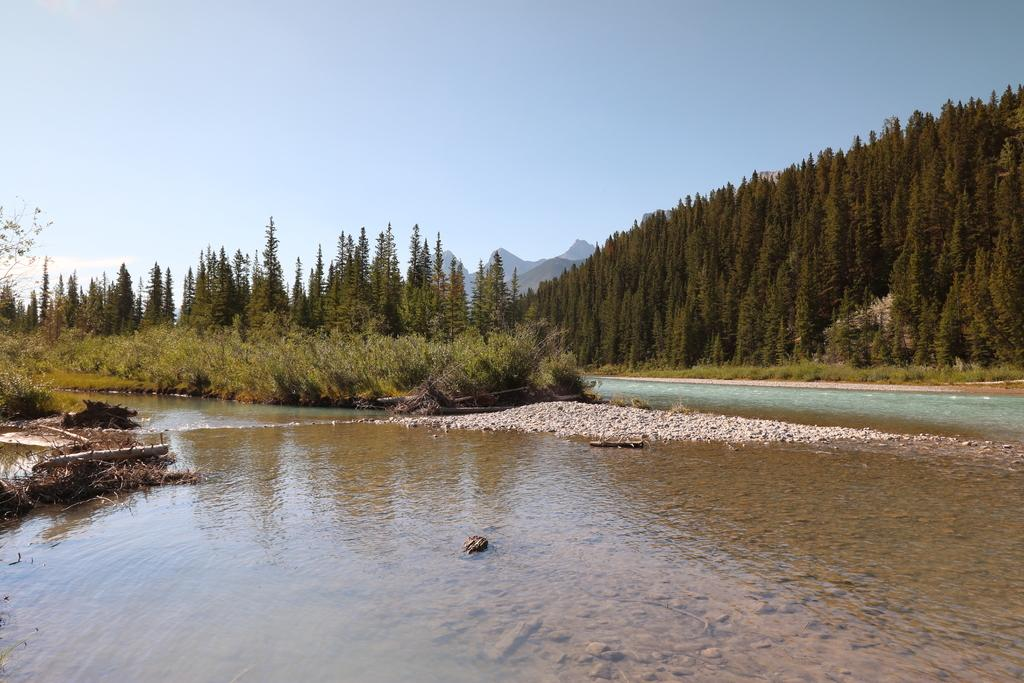What is the main subject in the center of the image? There is water in the center of the image. What can be seen in the background of the image? There are trees and hills in the background of the image. How would you describe the sky in the image? The sky is cloudy in the image. Where is the guitar placed in the image? There is no guitar present in the image. Is there any snow visible in the image? There is no snow visible in the image. 